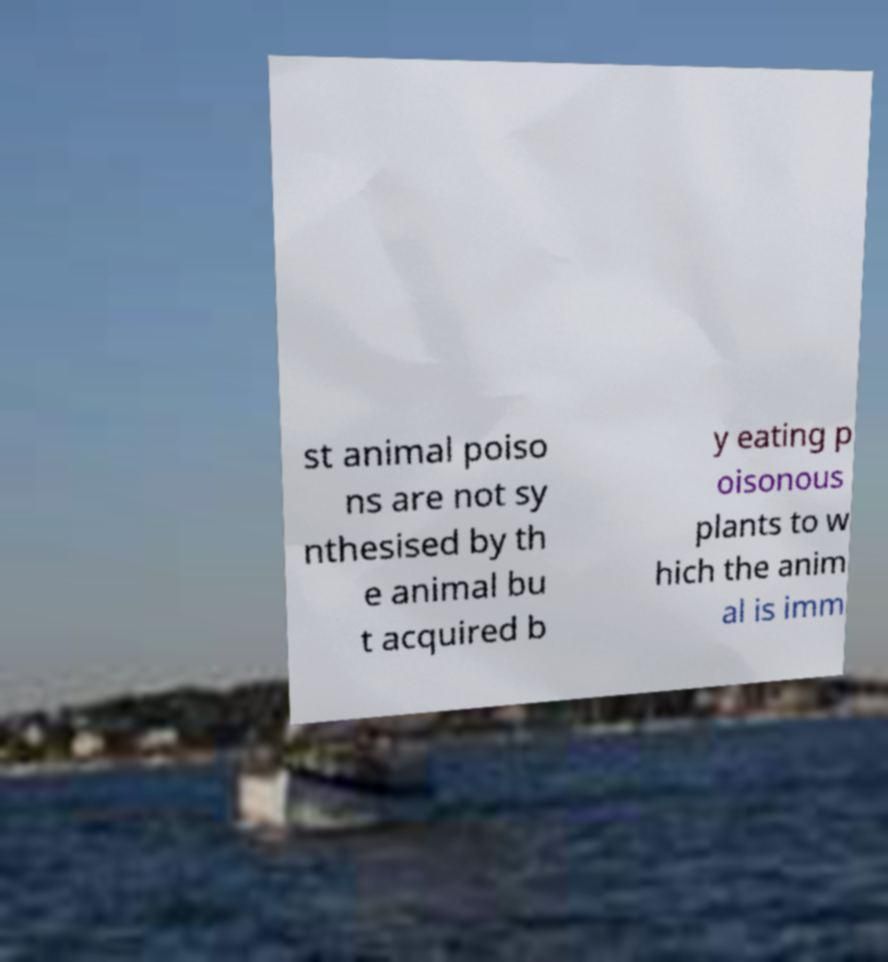I need the written content from this picture converted into text. Can you do that? st animal poiso ns are not sy nthesised by th e animal bu t acquired b y eating p oisonous plants to w hich the anim al is imm 